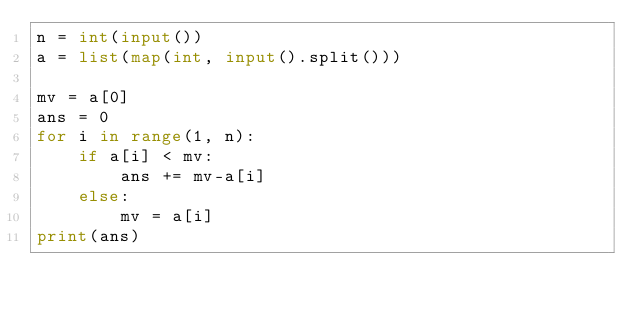<code> <loc_0><loc_0><loc_500><loc_500><_Python_>n = int(input())
a = list(map(int, input().split()))

mv = a[0]
ans = 0
for i in range(1, n):
    if a[i] < mv:
        ans += mv-a[i]
    else:
        mv = a[i]
print(ans)</code> 